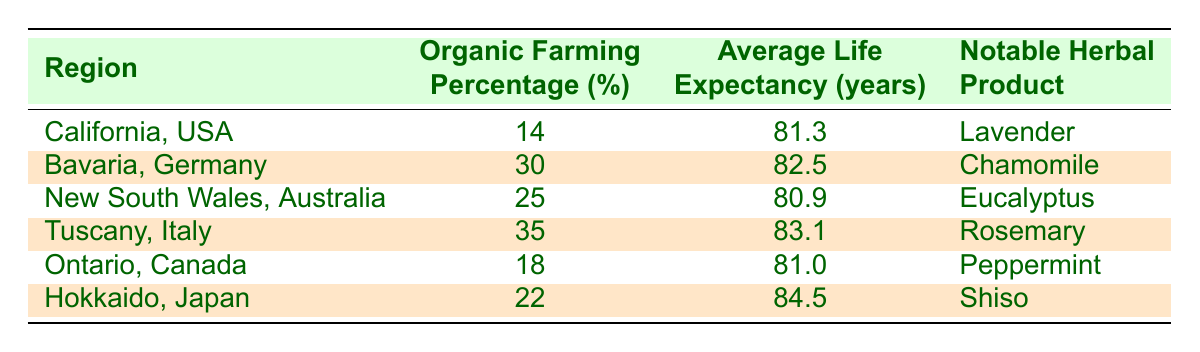What is the average life expectancy in Hokkaido, Japan? The average life expectancy for Hokkaido, Japan, as listed in the table, is 84.5 years.
Answer: 84.5 Which region has the highest organic farming percentage? Tuscany, Italy, has the highest organic farming percentage at 35%.
Answer: Tuscany, Italy What herbal product is associated with Bavaria, Germany? The notable herbal product associated with Bavaria, Germany, is Chamomile, as indicated in the table.
Answer: Chamomile Is the average life expectancy in New South Wales, Australia, greater than in California, USA? The average life expectancy in New South Wales (80.9 years) is less than that in California (81.3 years), making the statement false.
Answer: No Calculate the average organic farming percentage across all regions. To find the average organic farming percentage, add all the percentages: 14 + 30 + 25 + 35 + 18 + 22 = 144, then divide by the number of regions (6): 144 / 6 = 24%.
Answer: 24 Does Hokkaido, Japan, have a higher life expectancy than Tuscany, Italy? Hokkaido has an average life expectancy of 84.5 years, while Tuscany has 83.1 years, indicating Hokkaido has a higher life expectancy.
Answer: Yes What percentage of organic farming is practiced in Ontario, Canada? The table indicates that Ontario, Canada, has an organic farming percentage of 18%.
Answer: 18 Which region has the lowest average life expectancy? New South Wales, Australia, has the lowest average life expectancy at 80.9 years, according to the table.
Answer: New South Wales, Australia Is the notable herbal product of Hokkaido, Japan, Shiso? The table lists Shiso as the notable herbal product of Hokkaido, Japan, confirming the statement as true.
Answer: Yes 